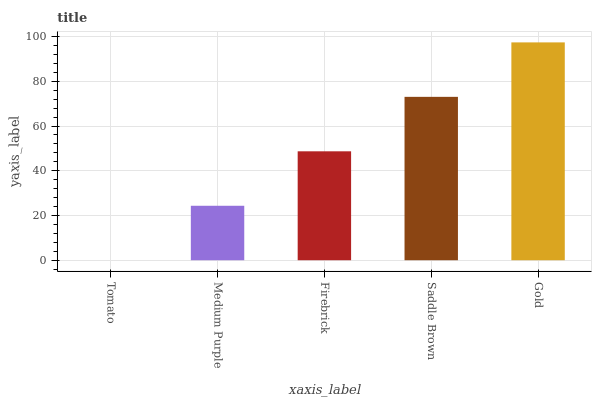Is Tomato the minimum?
Answer yes or no. Yes. Is Gold the maximum?
Answer yes or no. Yes. Is Medium Purple the minimum?
Answer yes or no. No. Is Medium Purple the maximum?
Answer yes or no. No. Is Medium Purple greater than Tomato?
Answer yes or no. Yes. Is Tomato less than Medium Purple?
Answer yes or no. Yes. Is Tomato greater than Medium Purple?
Answer yes or no. No. Is Medium Purple less than Tomato?
Answer yes or no. No. Is Firebrick the high median?
Answer yes or no. Yes. Is Firebrick the low median?
Answer yes or no. Yes. Is Saddle Brown the high median?
Answer yes or no. No. Is Tomato the low median?
Answer yes or no. No. 